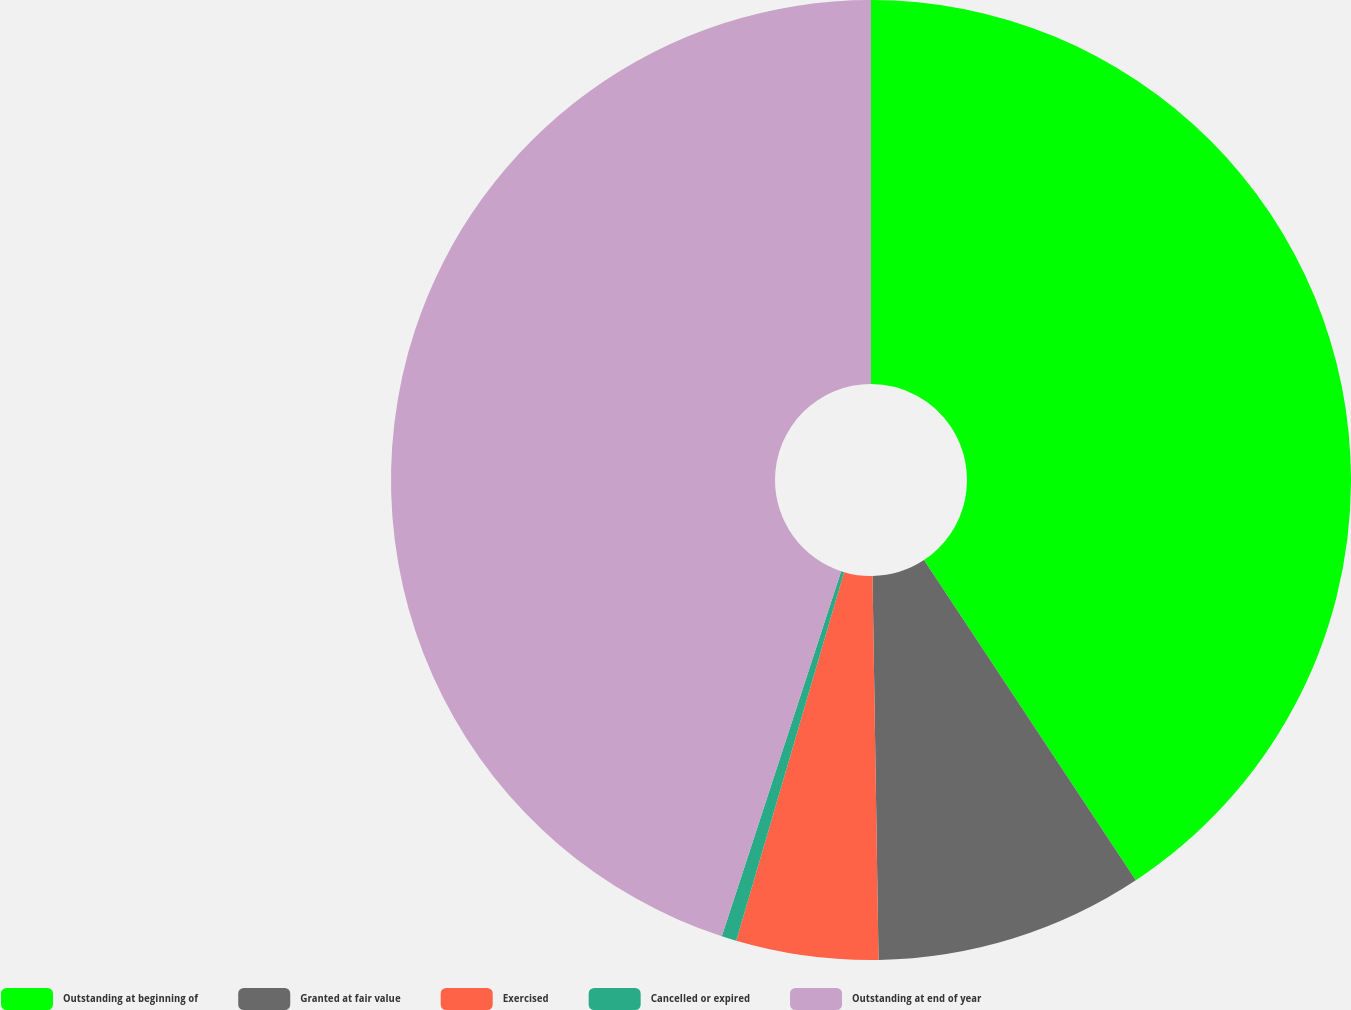<chart> <loc_0><loc_0><loc_500><loc_500><pie_chart><fcel>Outstanding at beginning of<fcel>Granted at fair value<fcel>Exercised<fcel>Cancelled or expired<fcel>Outstanding at end of year<nl><fcel>40.7%<fcel>9.05%<fcel>4.78%<fcel>0.5%<fcel>44.97%<nl></chart> 